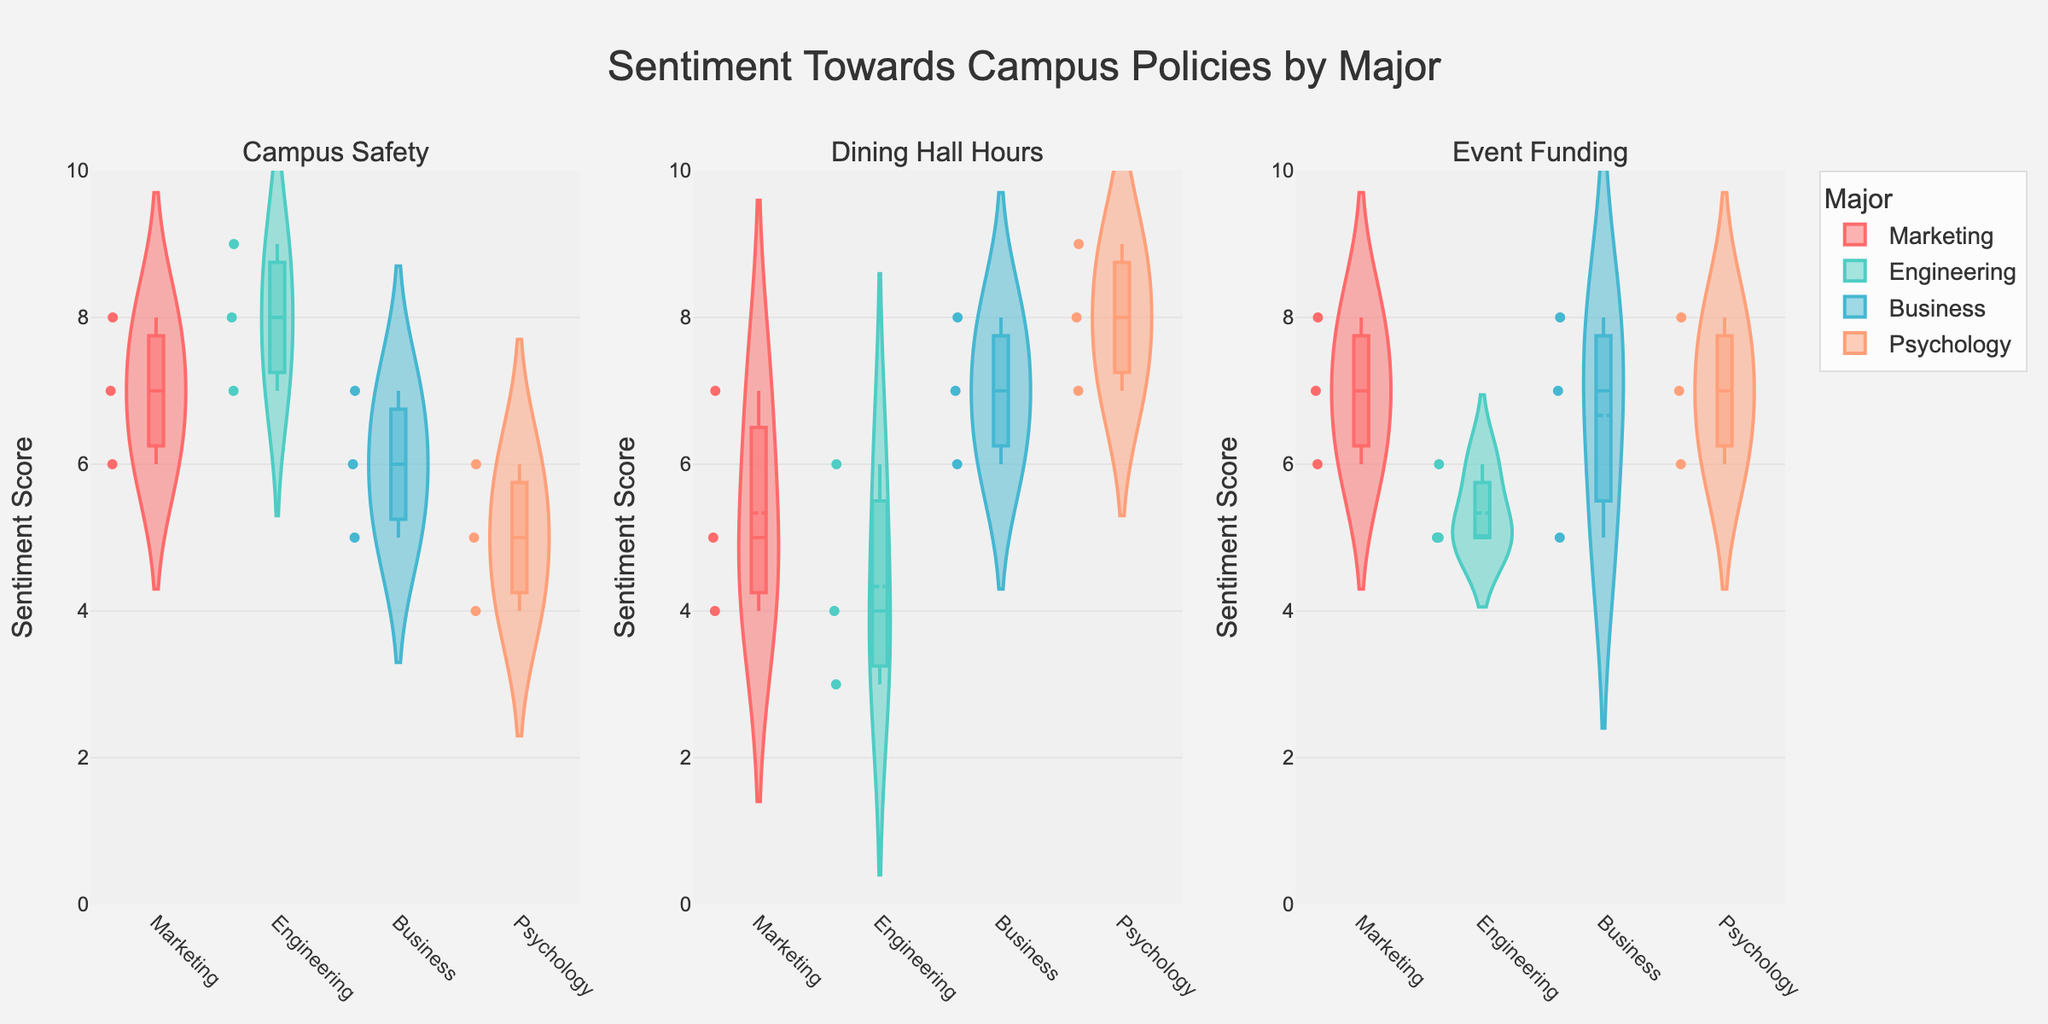How many distinct majors are represented in the figure? The figure shows sentiments towards campus policies segmented by majors. By looking at the x-axis and the legend, we can see distinct colors representing four different majors.
Answer: 4 Which policy has the highest median sentiment score among Marketing majors? In the subplots for the policies, each violin plot shows a box plot representing the median sentiment score. By observing the box plot for Marketing majors, the median sentiment score for Marketing is highest in "Event Funding."
Answer: Event Funding What is the range of sentiments for the "Campus Safety" policy among Psychology majors? The violin plot for "Campus Safety" shows the spread of sentiment scores. For Psychology majors, the sentiments range from 4 to 6.
Answer: 4 to 6 Which major shows the most variability in sentiment towards "Dining Hall Hours"? Variability can be assessed by looking at the width and spread of the violin plots. In the "Dining Hall Hours" subplot, Psychology majors have the widest and most spread-out violin plot, indicating the most variability.
Answer: Psychology Compare the median sentiments for "Event Funding" between Business and Engineering majors. By examining the box plots within the "Event Funding" violin plots, we can observe that the median for Business is higher than the median for Engineering majors.
Answer: Business > Engineering What is the prominent color of the line marking the mean sentiment score for Marketing majors? When looking at the violin plots, each major is represented by a different color. Marketing majors have their mean line marked in red.
Answer: Red Which policy exhibits the closest sentiment ranges between Marketing and Engineering majors? To find the closest sentiment ranges, we compare the spread of the violin plots for each policy. "Event Funding" shows the closest ranges between Marketing and Engineering majors, with noticeable overlap.
Answer: Event Funding Identify one major where the sentiment towards "Campus Safety" never drops below 7. Observing the "Campus Safety" violin plots, the sentiment towards this policy for Engineering majors never drops below 7.
Answer: Engineering For which major is the median sentiment towards "Dining Hall Hours" greater than the upper quartile (75th percentile) sentiment towards "Event Funding"? By examining the box plots, we find that for Business majors, the median sentiment towards "Dining Hall Hours" is 7.5, which is greater than the upper quartile sentiment (around 6.5) towards "Event Funding."
Answer: Business 